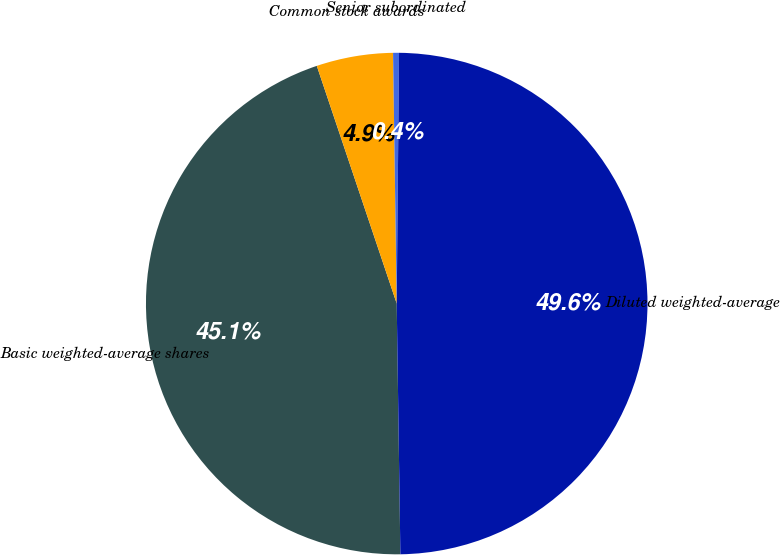Convert chart. <chart><loc_0><loc_0><loc_500><loc_500><pie_chart><fcel>Basic weighted-average shares<fcel>Common stock awards<fcel>Senior subordinated<fcel>Diluted weighted-average<nl><fcel>45.07%<fcel>4.93%<fcel>0.38%<fcel>49.62%<nl></chart> 